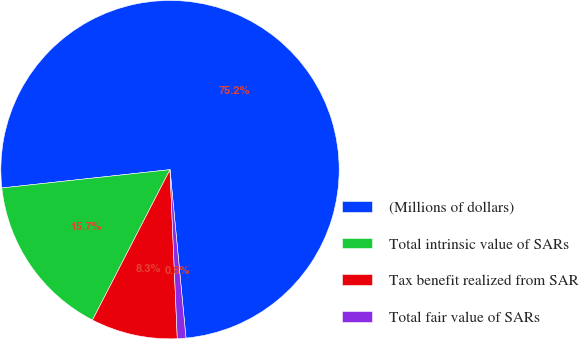<chart> <loc_0><loc_0><loc_500><loc_500><pie_chart><fcel>(Millions of dollars)<fcel>Total intrinsic value of SARs<fcel>Tax benefit realized from SAR<fcel>Total fair value of SARs<nl><fcel>75.22%<fcel>15.7%<fcel>8.26%<fcel>0.82%<nl></chart> 